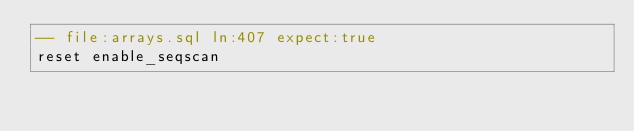<code> <loc_0><loc_0><loc_500><loc_500><_SQL_>-- file:arrays.sql ln:407 expect:true
reset enable_seqscan
</code> 